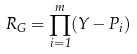<formula> <loc_0><loc_0><loc_500><loc_500>R _ { G } = \prod _ { i = 1 } ^ { m } ( Y - P _ { i } )</formula> 